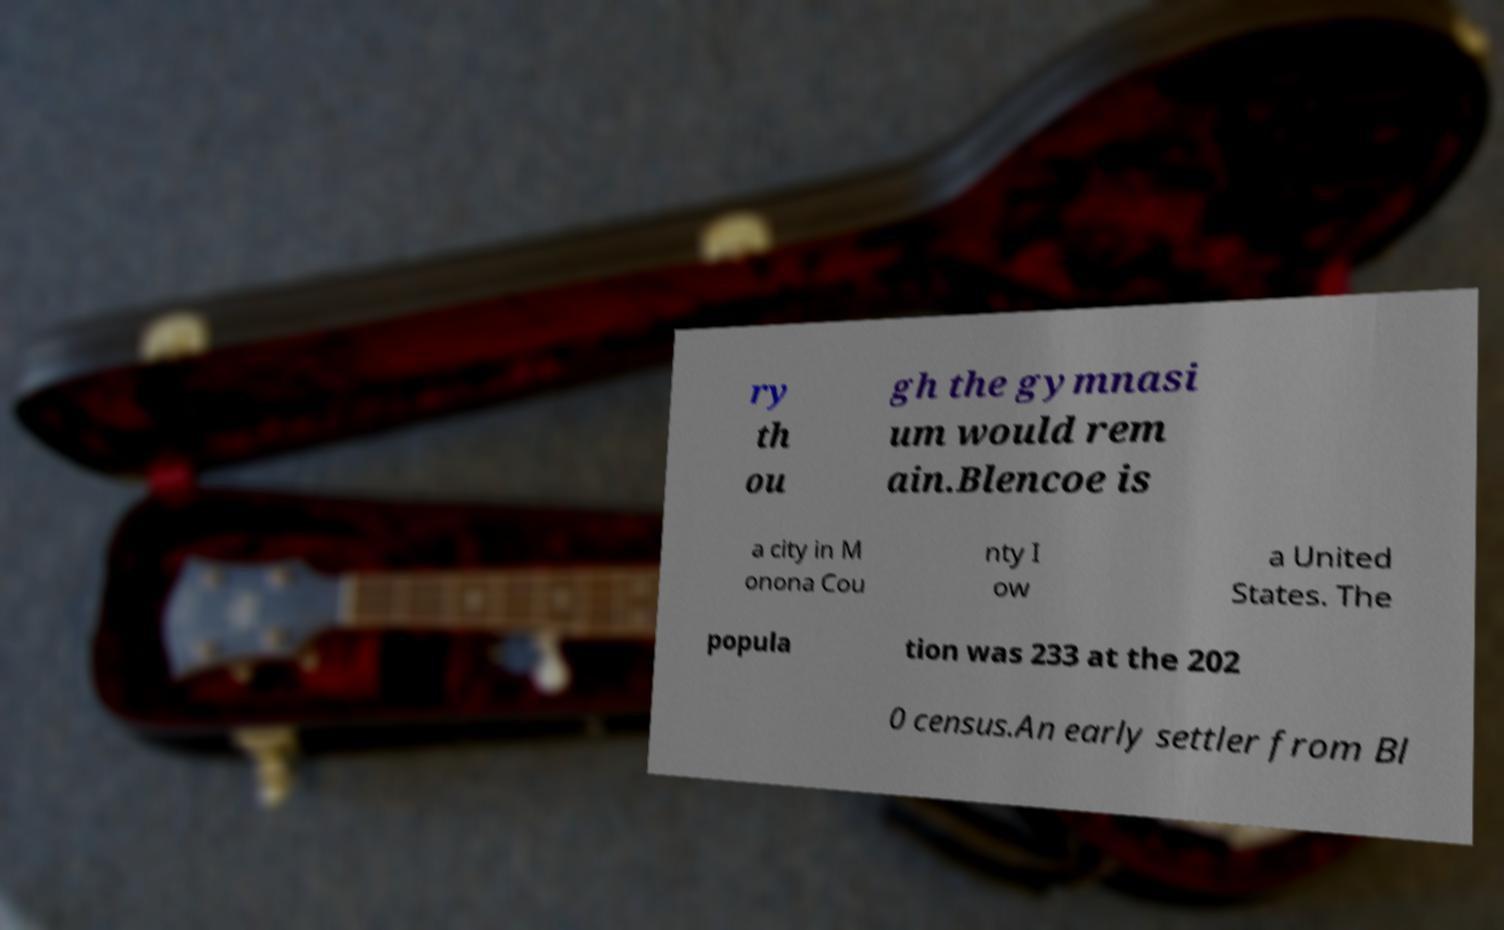There's text embedded in this image that I need extracted. Can you transcribe it verbatim? ry th ou gh the gymnasi um would rem ain.Blencoe is a city in M onona Cou nty I ow a United States. The popula tion was 233 at the 202 0 census.An early settler from Bl 